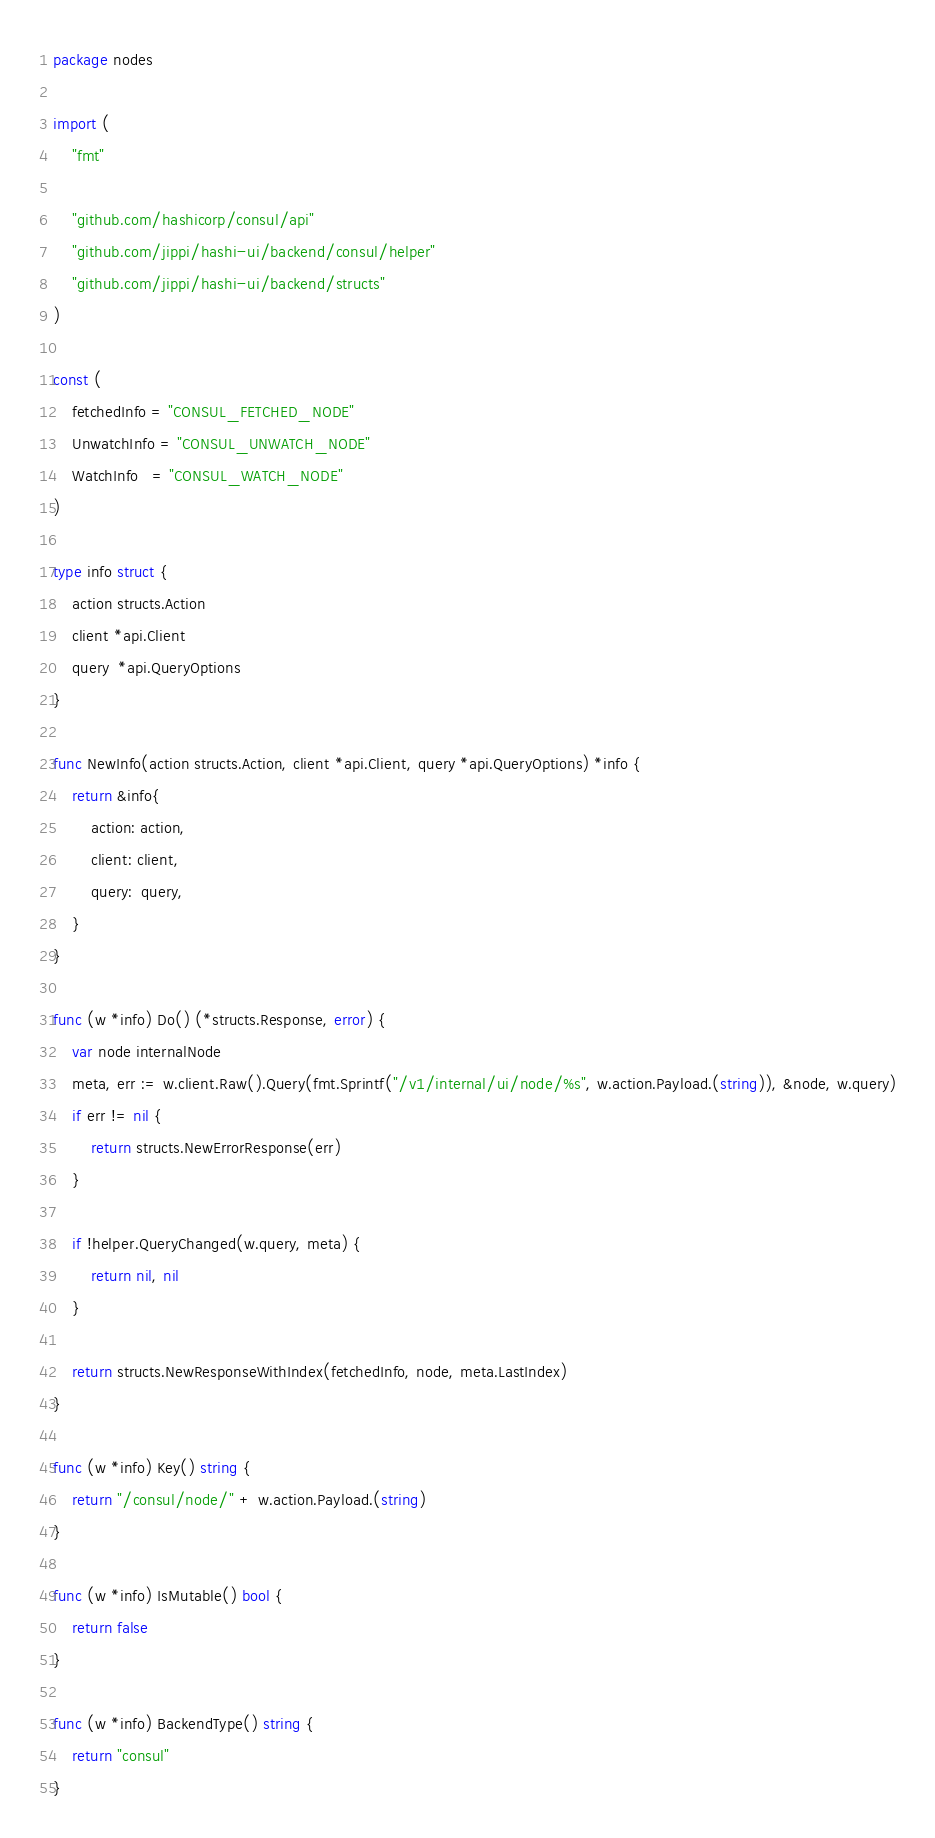Convert code to text. <code><loc_0><loc_0><loc_500><loc_500><_Go_>package nodes

import (
	"fmt"

	"github.com/hashicorp/consul/api"
	"github.com/jippi/hashi-ui/backend/consul/helper"
	"github.com/jippi/hashi-ui/backend/structs"
)

const (
	fetchedInfo = "CONSUL_FETCHED_NODE"
	UnwatchInfo = "CONSUL_UNWATCH_NODE"
	WatchInfo   = "CONSUL_WATCH_NODE"
)

type info struct {
	action structs.Action
	client *api.Client
	query  *api.QueryOptions
}

func NewInfo(action structs.Action, client *api.Client, query *api.QueryOptions) *info {
	return &info{
		action: action,
		client: client,
		query:  query,
	}
}

func (w *info) Do() (*structs.Response, error) {
	var node internalNode
	meta, err := w.client.Raw().Query(fmt.Sprintf("/v1/internal/ui/node/%s", w.action.Payload.(string)), &node, w.query)
	if err != nil {
		return structs.NewErrorResponse(err)
	}

	if !helper.QueryChanged(w.query, meta) {
		return nil, nil
	}

	return structs.NewResponseWithIndex(fetchedInfo, node, meta.LastIndex)
}

func (w *info) Key() string {
	return "/consul/node/" + w.action.Payload.(string)
}

func (w *info) IsMutable() bool {
	return false
}

func (w *info) BackendType() string {
	return "consul"
}
</code> 